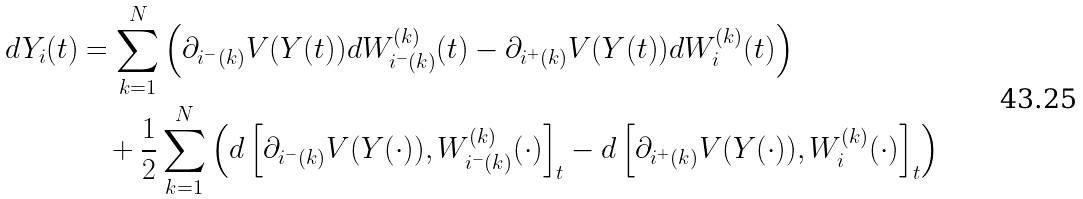<formula> <loc_0><loc_0><loc_500><loc_500>d Y _ { i } ( t ) & = \sum _ { k = 1 } ^ { N } \left ( \partial _ { { i } ^ { - } ( k ) } V ( Y ( t ) ) d W _ { { i } ^ { - } ( k ) } ^ { ( k ) } ( t ) - \partial _ { { i } ^ { + } ( k ) } V ( Y ( t ) ) d W _ { i } ^ { ( k ) } ( t ) \right ) \\ & \quad + \frac { 1 } { 2 } \sum _ { k = 1 } ^ { N } \left ( d \left [ \partial _ { { i } ^ { - } ( k ) } V ( Y ( \cdot ) ) , W ^ { ( k ) } _ { { i } ^ { - } ( k ) } ( \cdot ) \right ] _ { t } - d \left [ \partial _ { { i } ^ { + } ( k ) } V ( Y ( \cdot ) ) , W ^ { ( k ) } _ { i } ( \cdot ) \right ] _ { t } \right )</formula> 